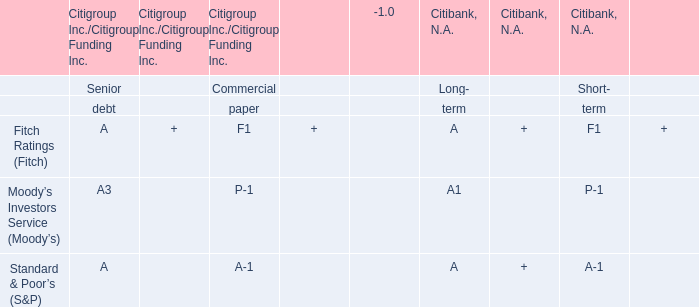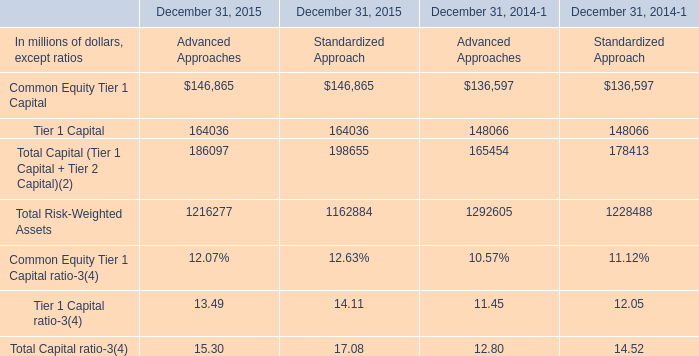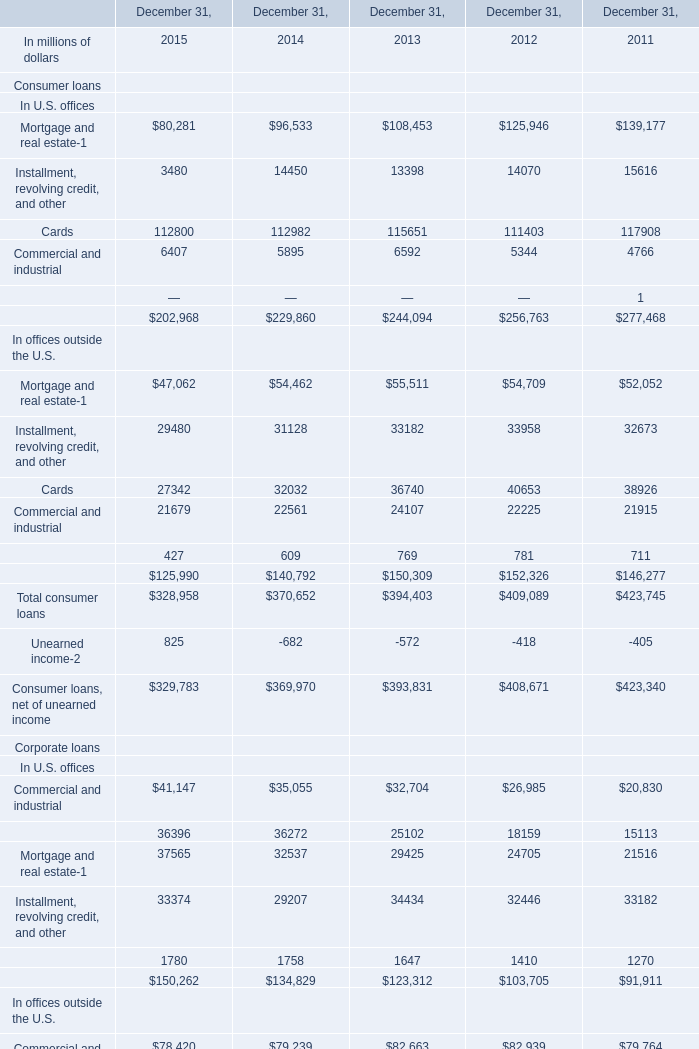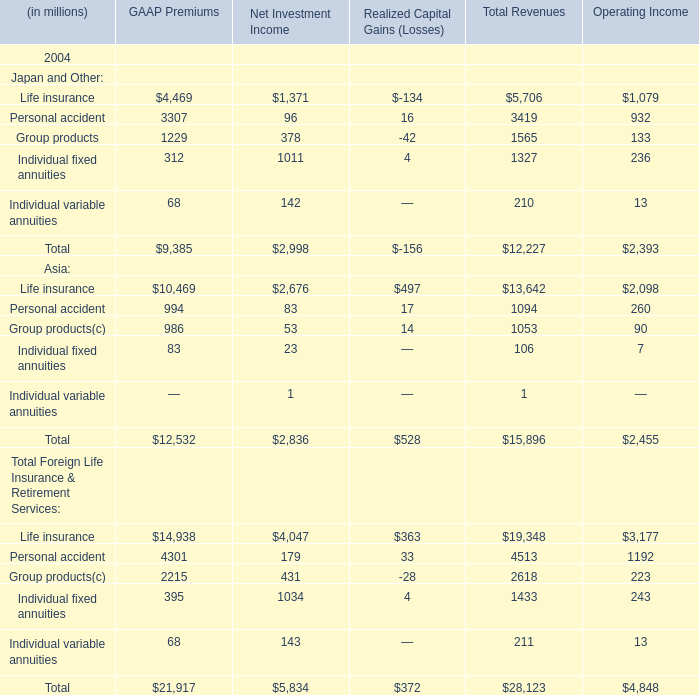what's the total amount of Commercial and industrial of December 31, 2015, Individual fixed annuities of Net Investment Income, and Installment, revolving credit, and other In offices outside the U.S. of December 31, 2011 ? 
Computations: ((6407.0 + 1011.0) + 32673.0)
Answer: 40091.0. 